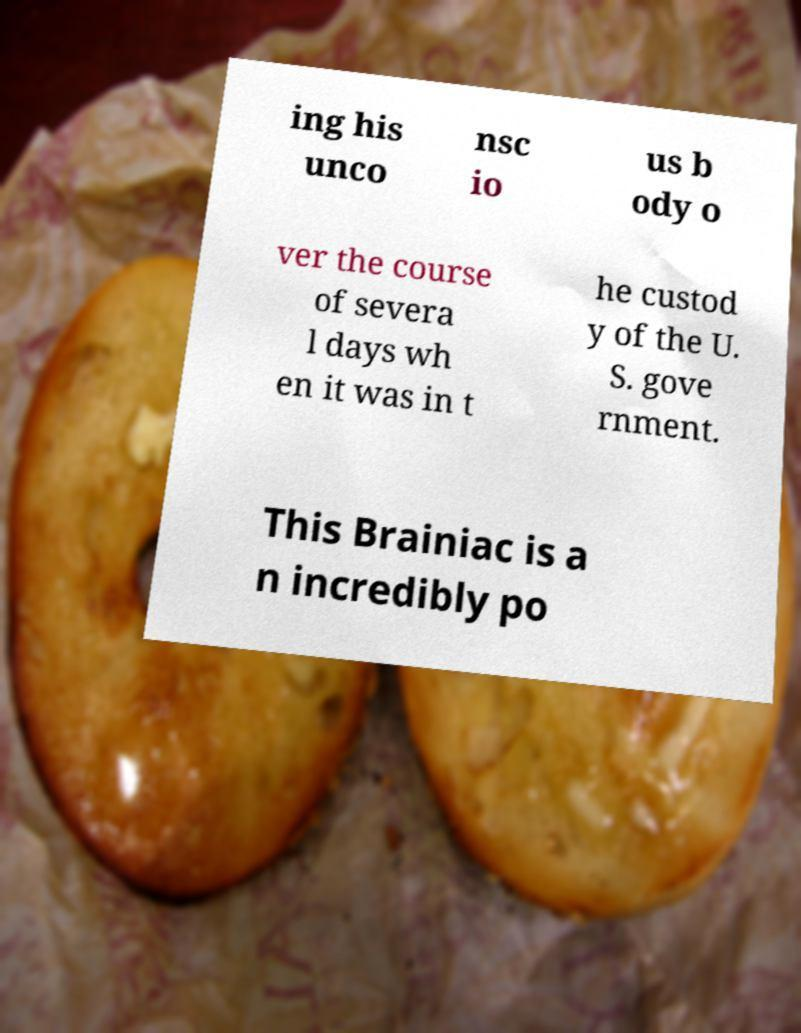There's text embedded in this image that I need extracted. Can you transcribe it verbatim? ing his unco nsc io us b ody o ver the course of severa l days wh en it was in t he custod y of the U. S. gove rnment. This Brainiac is a n incredibly po 